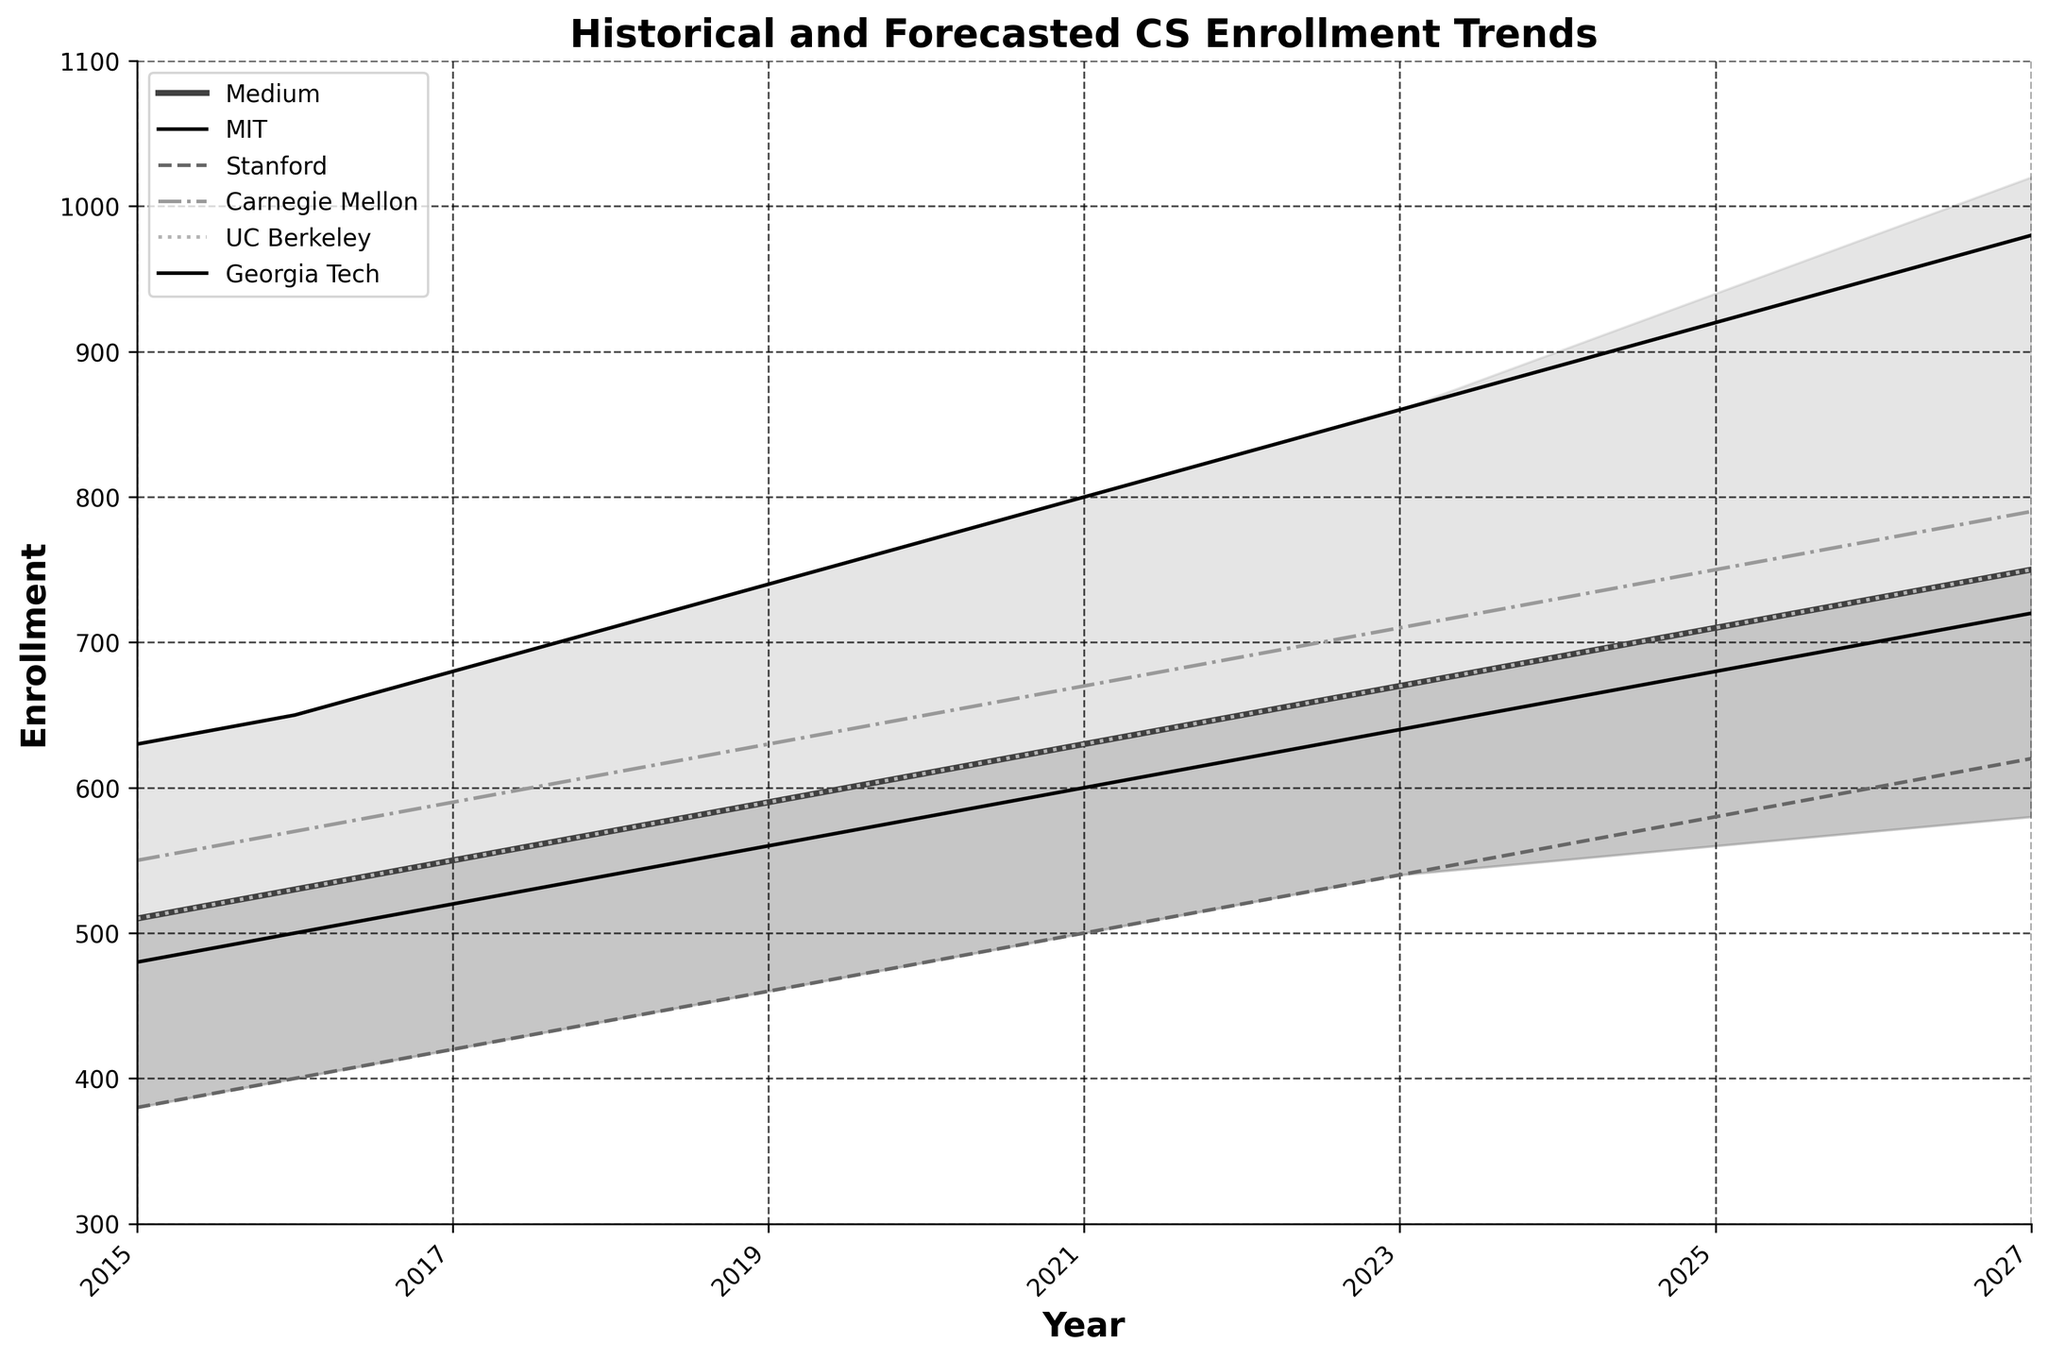What's the title of the plot? The title of a plot is usually found at the top and describes what the plot is about. In this case, it is written in a bold font and clearly states the focus of the plot.
Answer: Historical and Forecasted CS Enrollment Trends What is the enrollment for MIT in 2020? To find the enrollment for MIT in 2020, locate the curve labeled "MIT" and identify where it intersects the vertical line at 2020.
Answer: 770 Which university had the highest enrollment in 2023? To determine the university with the highest enrollment in 2023, find the data points for all universities at the year 2023 and compare their values.
Answer: MIT What is the range of forecasted enrollment values for 2025 according to the fan chart? To find the forecasted range for 2025, locate the year 2025 on the x-axis and check the values covered by the fan chart for that year, spanning from the low to the high predictions.
Answer: From 560 to 940 Which years show overlapping enrollment values for Carnegie Mellon and UC Berkeley? To determine the years with overlapping values, look for years where Carnegie Mellon's and UC Berkeley's lines intersect or closely align.
Answer: 2015 to 2021 What is the trend in enrollment for Georgia Tech from 2015 to 2027? To identify the trend, observe the general direction of the Georgia Tech line from 2015 to 2027. If it moves upwards, downwards, or remains stable, that indicates the trend.
Answer: Increasing How much is the difference in MIT's enrollment between 2022 and 2026? To find the difference, subtract MIT's enrollment value for 2022 from that for 2026.
Answer: 950 - 830 = 120 What is the percentage increase in Stanford's enrollment from 2015 to 2027? First, calculate the absolute increase (620 - 380), then divide by the initial value (380), and multiply by 100 to get the percentage increase.
Answer: ((620 - 380) / 380) * 100 = 63.16% Which university shows the most variability in enrollment over the years? To determine which university has the most variability, compare the lines for all universities and observe which one fluctuates the most or has the steepest inclines and declines.
Answer: UC Berkeley Does the medium forecast remain within the fan chart's high and low values throughout the years? Check if the medium forecast line stays consistently between the high and low lines of the fan chart from the start to the end year.
Answer: Yes 